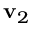Convert formula to latex. <formula><loc_0><loc_0><loc_500><loc_500>v _ { 2 }</formula> 